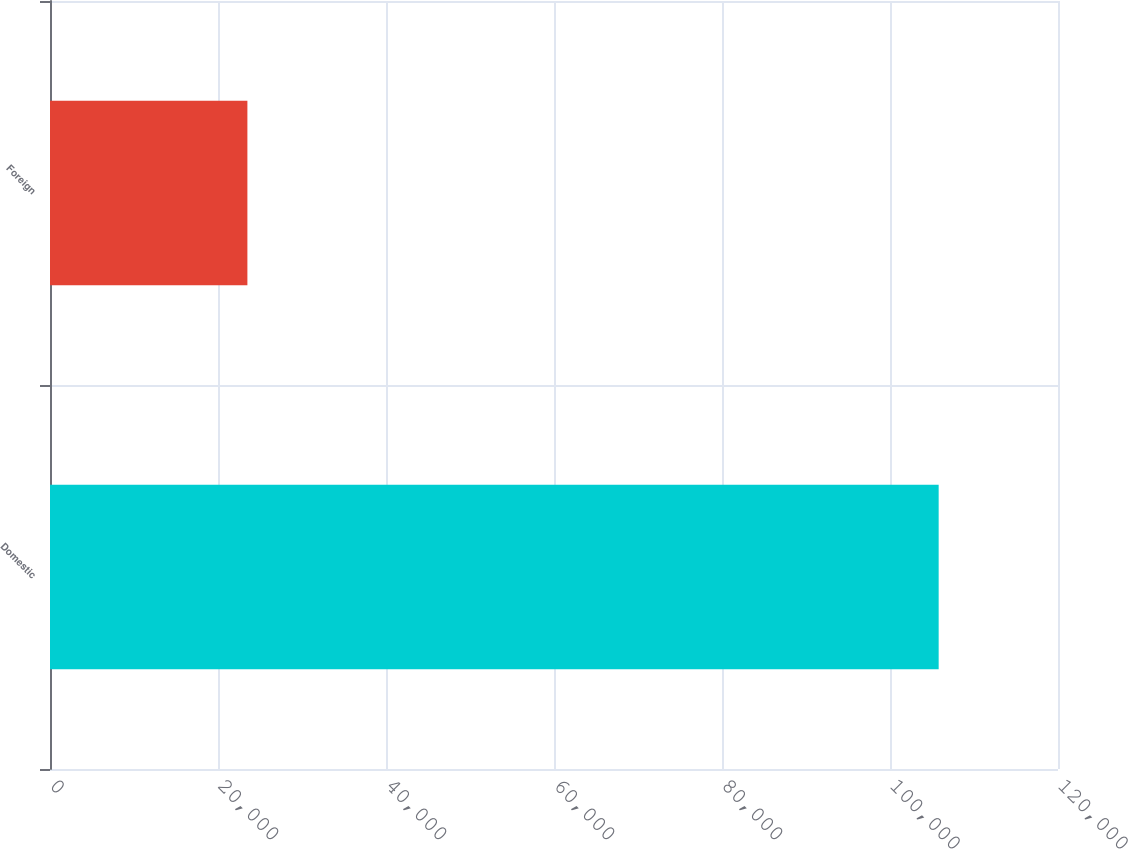Convert chart to OTSL. <chart><loc_0><loc_0><loc_500><loc_500><bar_chart><fcel>Domestic<fcel>Foreign<nl><fcel>105793<fcel>23499<nl></chart> 